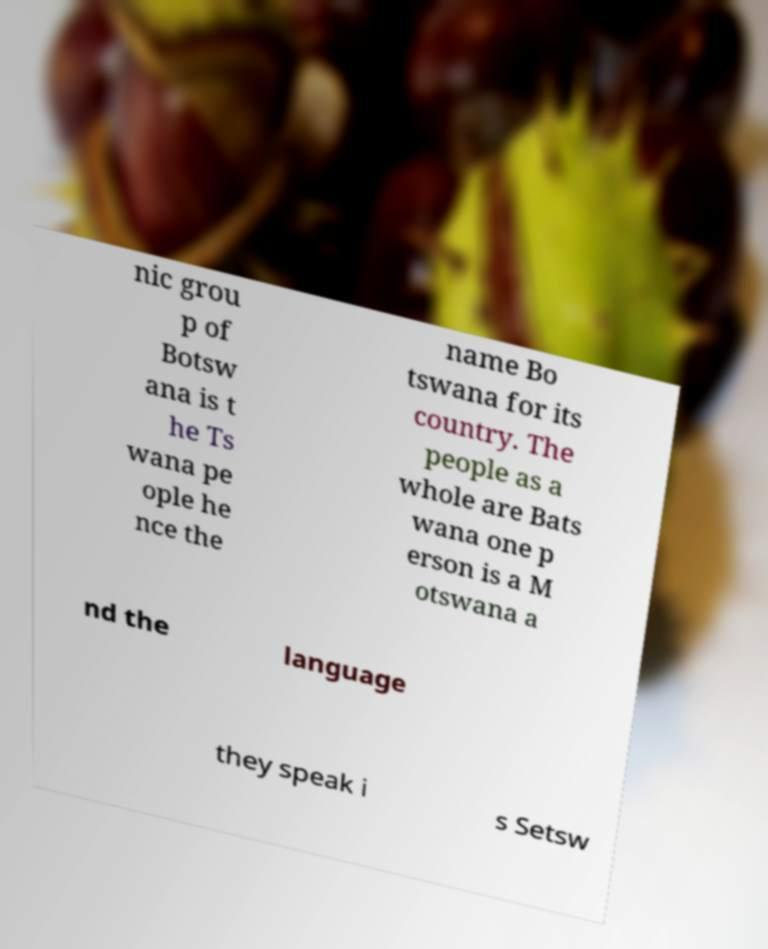Can you read and provide the text displayed in the image?This photo seems to have some interesting text. Can you extract and type it out for me? nic grou p of Botsw ana is t he Ts wana pe ople he nce the name Bo tswana for its country. The people as a whole are Bats wana one p erson is a M otswana a nd the language they speak i s Setsw 